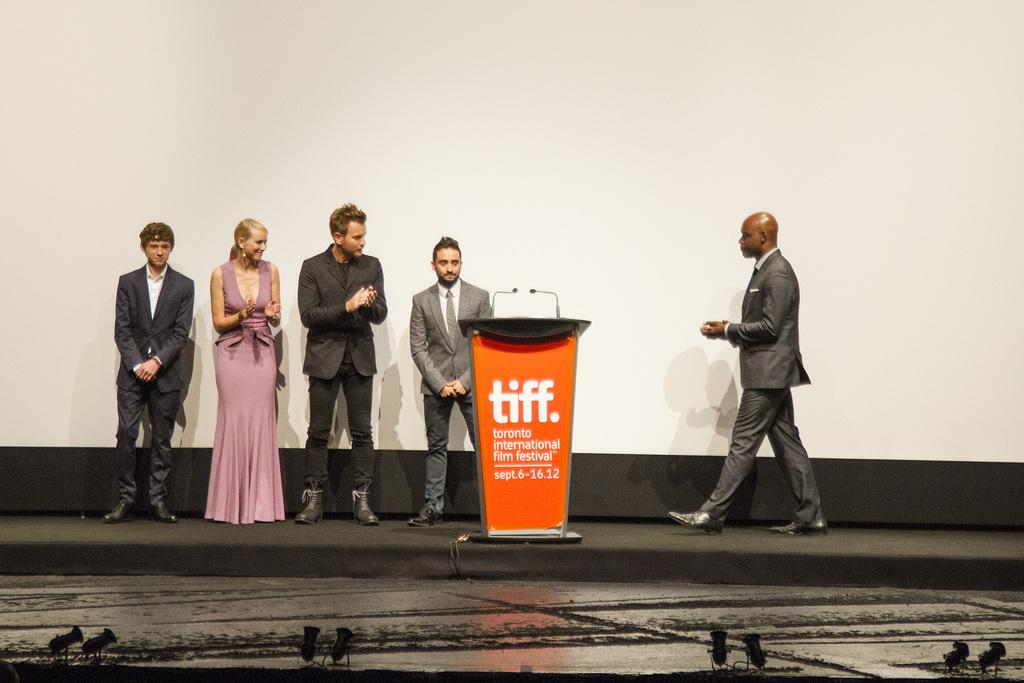What are the people in the image doing near the board? The people in the image are standing near a board. Can you describe the action of one person in the image? One person is walking in the image. How many cats are sitting on the sheet in the image? There are no cats or sheets present in the image. What type of transport is being used by the people in the image? The image does not show any form of transport; it only shows people standing near a board and one person walking. 